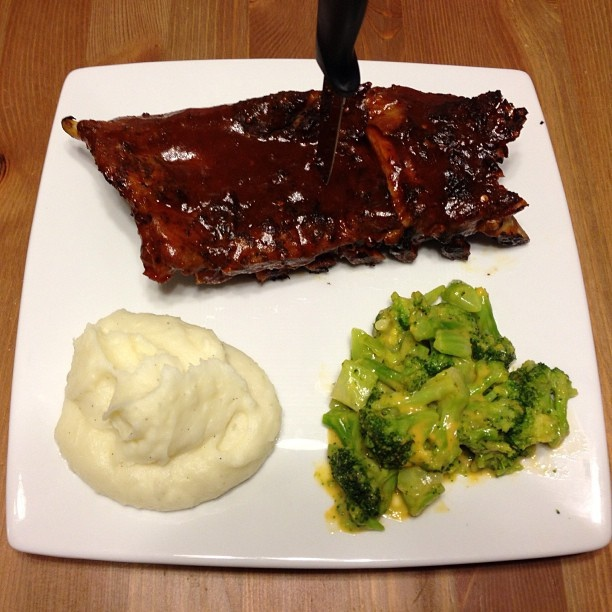Describe the objects in this image and their specific colors. I can see broccoli in maroon, olive, and black tones and knife in maroon, black, and gray tones in this image. 